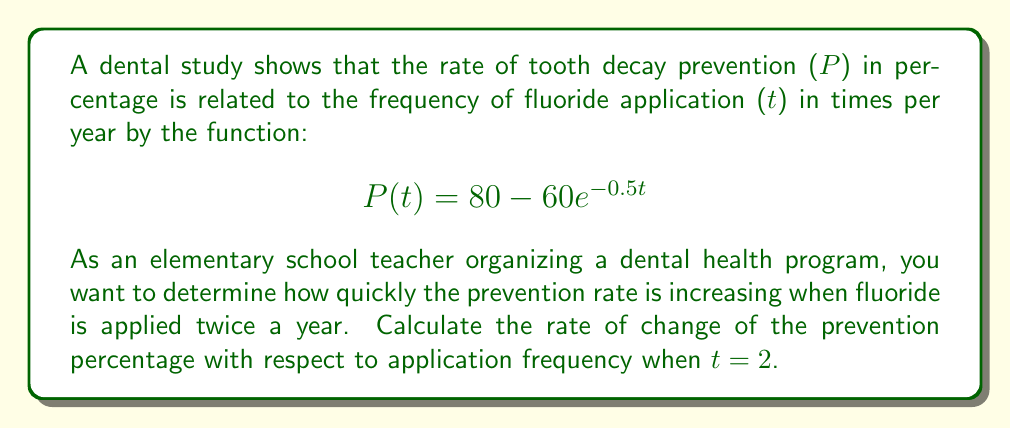Can you answer this question? To solve this problem, we need to find the derivative of P(t) with respect to t and then evaluate it at t = 2. Let's break it down step-by-step:

1. Given function: $$P(t) = 80 - 60e^{-0.5t}$$

2. To find the rate of change, we need to calculate $\frac{dP}{dt}$:
   $$\frac{dP}{dt} = \frac{d}{dt}(80 - 60e^{-0.5t})$$

3. The derivative of a constant (80) is 0, so we only need to focus on the exponential term:
   $$\frac{dP}{dt} = -60 \cdot \frac{d}{dt}(e^{-0.5t})$$

4. Using the chain rule, we get:
   $$\frac{dP}{dt} = -60 \cdot (-0.5) \cdot e^{-0.5t}$$

5. Simplify:
   $$\frac{dP}{dt} = 30e^{-0.5t}$$

6. Now, we evaluate this at t = 2:
   $$\left.\frac{dP}{dt}\right|_{t=2} = 30e^{-0.5(2)}$$

7. Simplify:
   $$\left.\frac{dP}{dt}\right|_{t=2} = 30e^{-1} \approx 11.04$$

This means that when fluoride is applied twice a year, the rate of tooth decay prevention is increasing by approximately 11.04 percentage points per additional application per year.
Answer: The rate of change of the prevention percentage with respect to application frequency when t = 2 is $30e^{-1} \approx 11.04$ percentage points per additional application per year. 